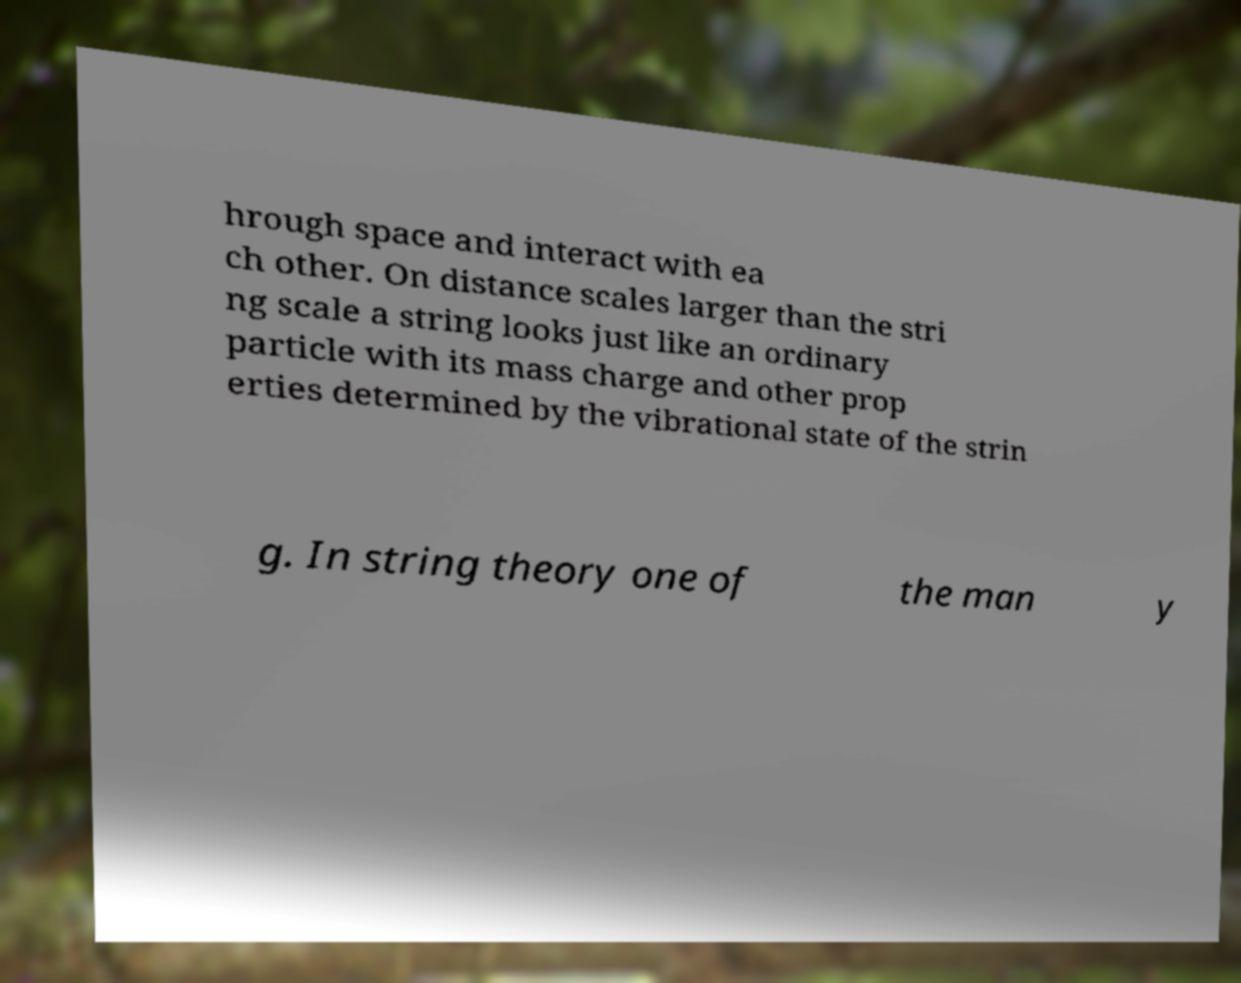Can you accurately transcribe the text from the provided image for me? hrough space and interact with ea ch other. On distance scales larger than the stri ng scale a string looks just like an ordinary particle with its mass charge and other prop erties determined by the vibrational state of the strin g. In string theory one of the man y 